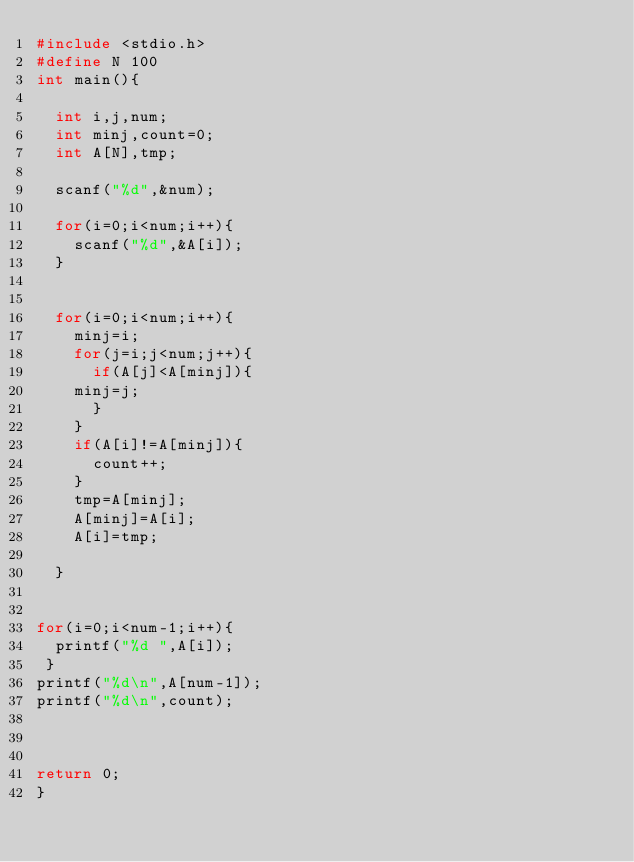<code> <loc_0><loc_0><loc_500><loc_500><_C_>#include <stdio.h>
#define N 100
int main(){

  int i,j,num;
  int minj,count=0;
  int A[N],tmp;

  scanf("%d",&num);
  
  for(i=0;i<num;i++){
    scanf("%d",&A[i]);
  }

 
  for(i=0;i<num;i++){
    minj=i;
    for(j=i;j<num;j++){
      if(A[j]<A[minj]){
	minj=j;
      }
    }
    if(A[i]!=A[minj]){
      count++;
    }
    tmp=A[minj];
    A[minj]=A[i];
    A[i]=tmp;
     
  }


for(i=0;i<num-1;i++){
  printf("%d ",A[i]);
 }
printf("%d\n",A[num-1]);
printf("%d\n",count);



return 0;
}

</code> 